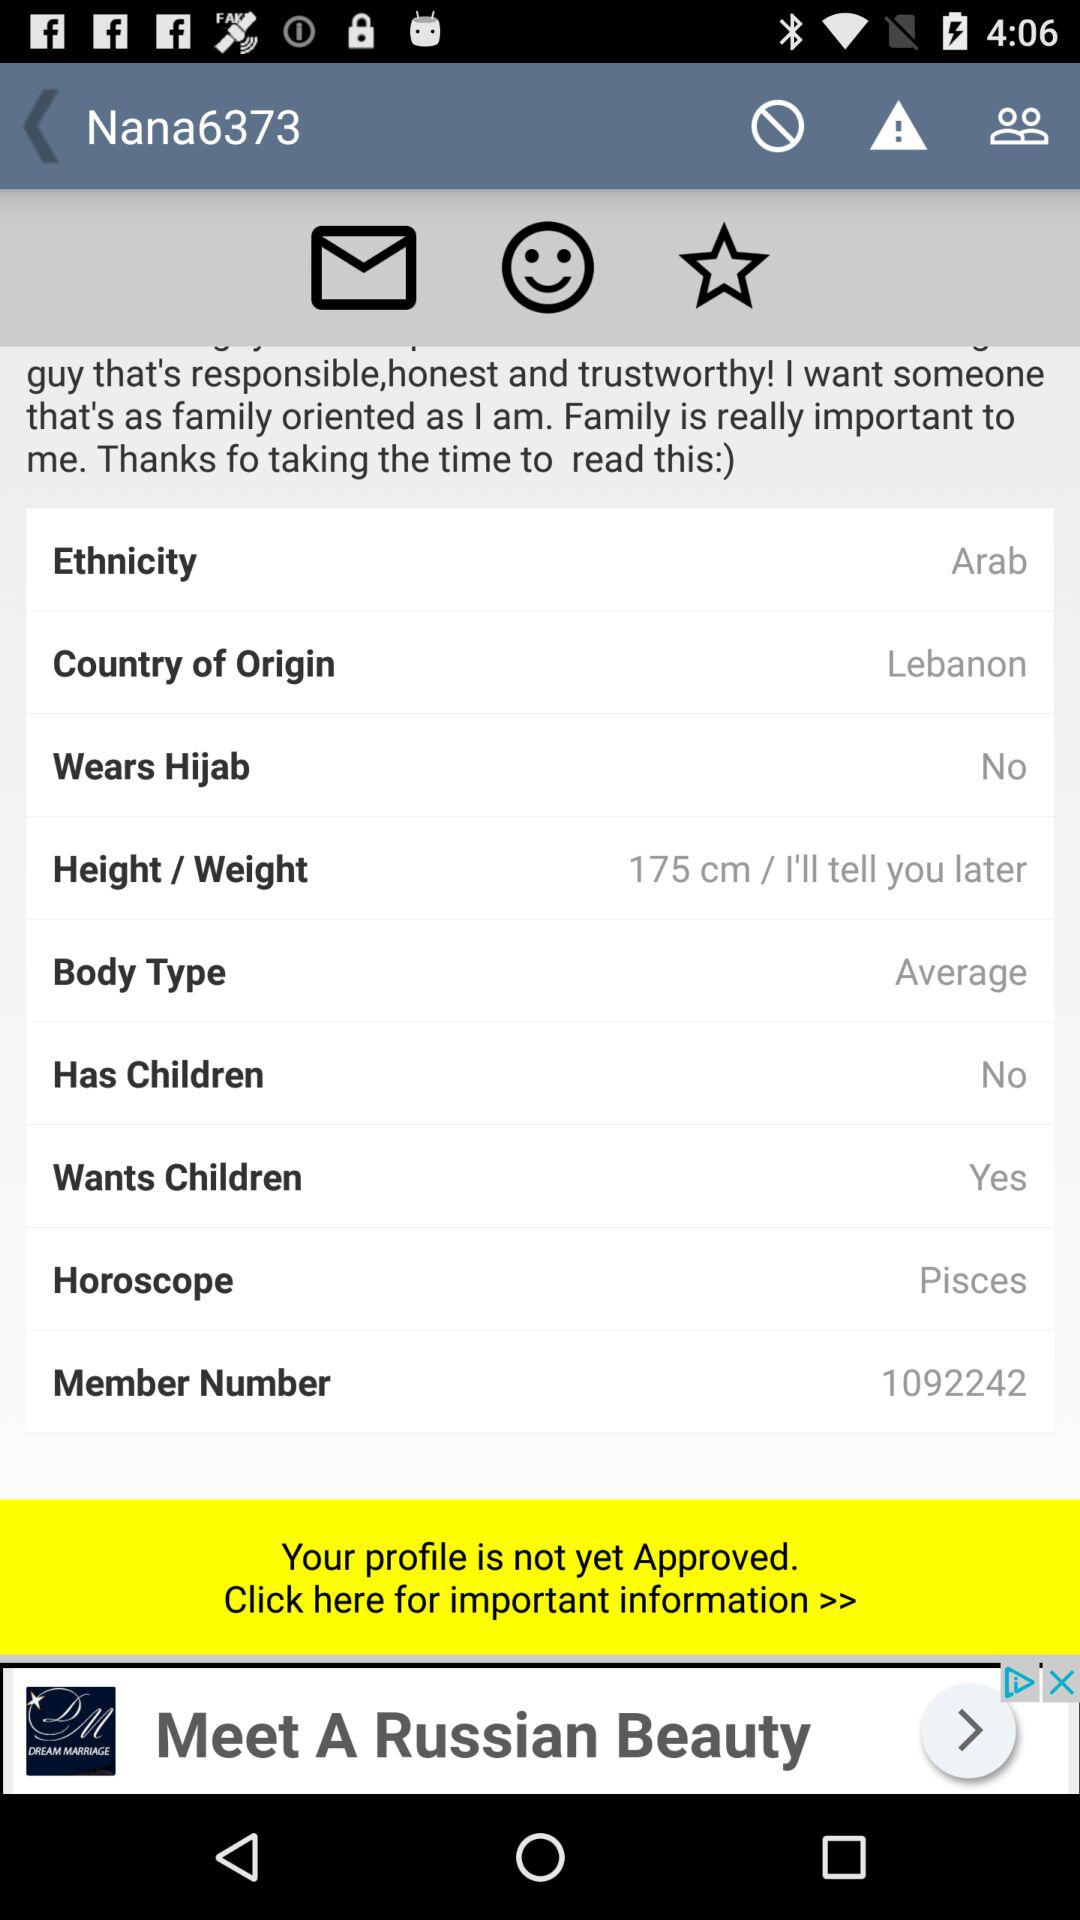What is the member number? The member number is 1092242. 